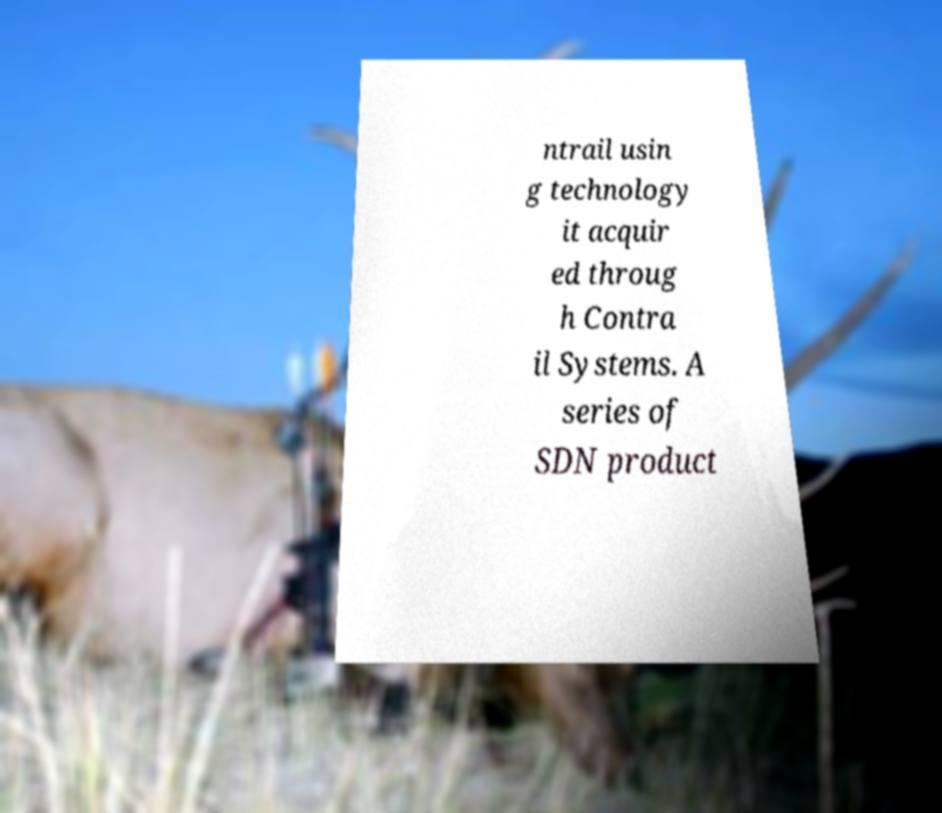For documentation purposes, I need the text within this image transcribed. Could you provide that? ntrail usin g technology it acquir ed throug h Contra il Systems. A series of SDN product 